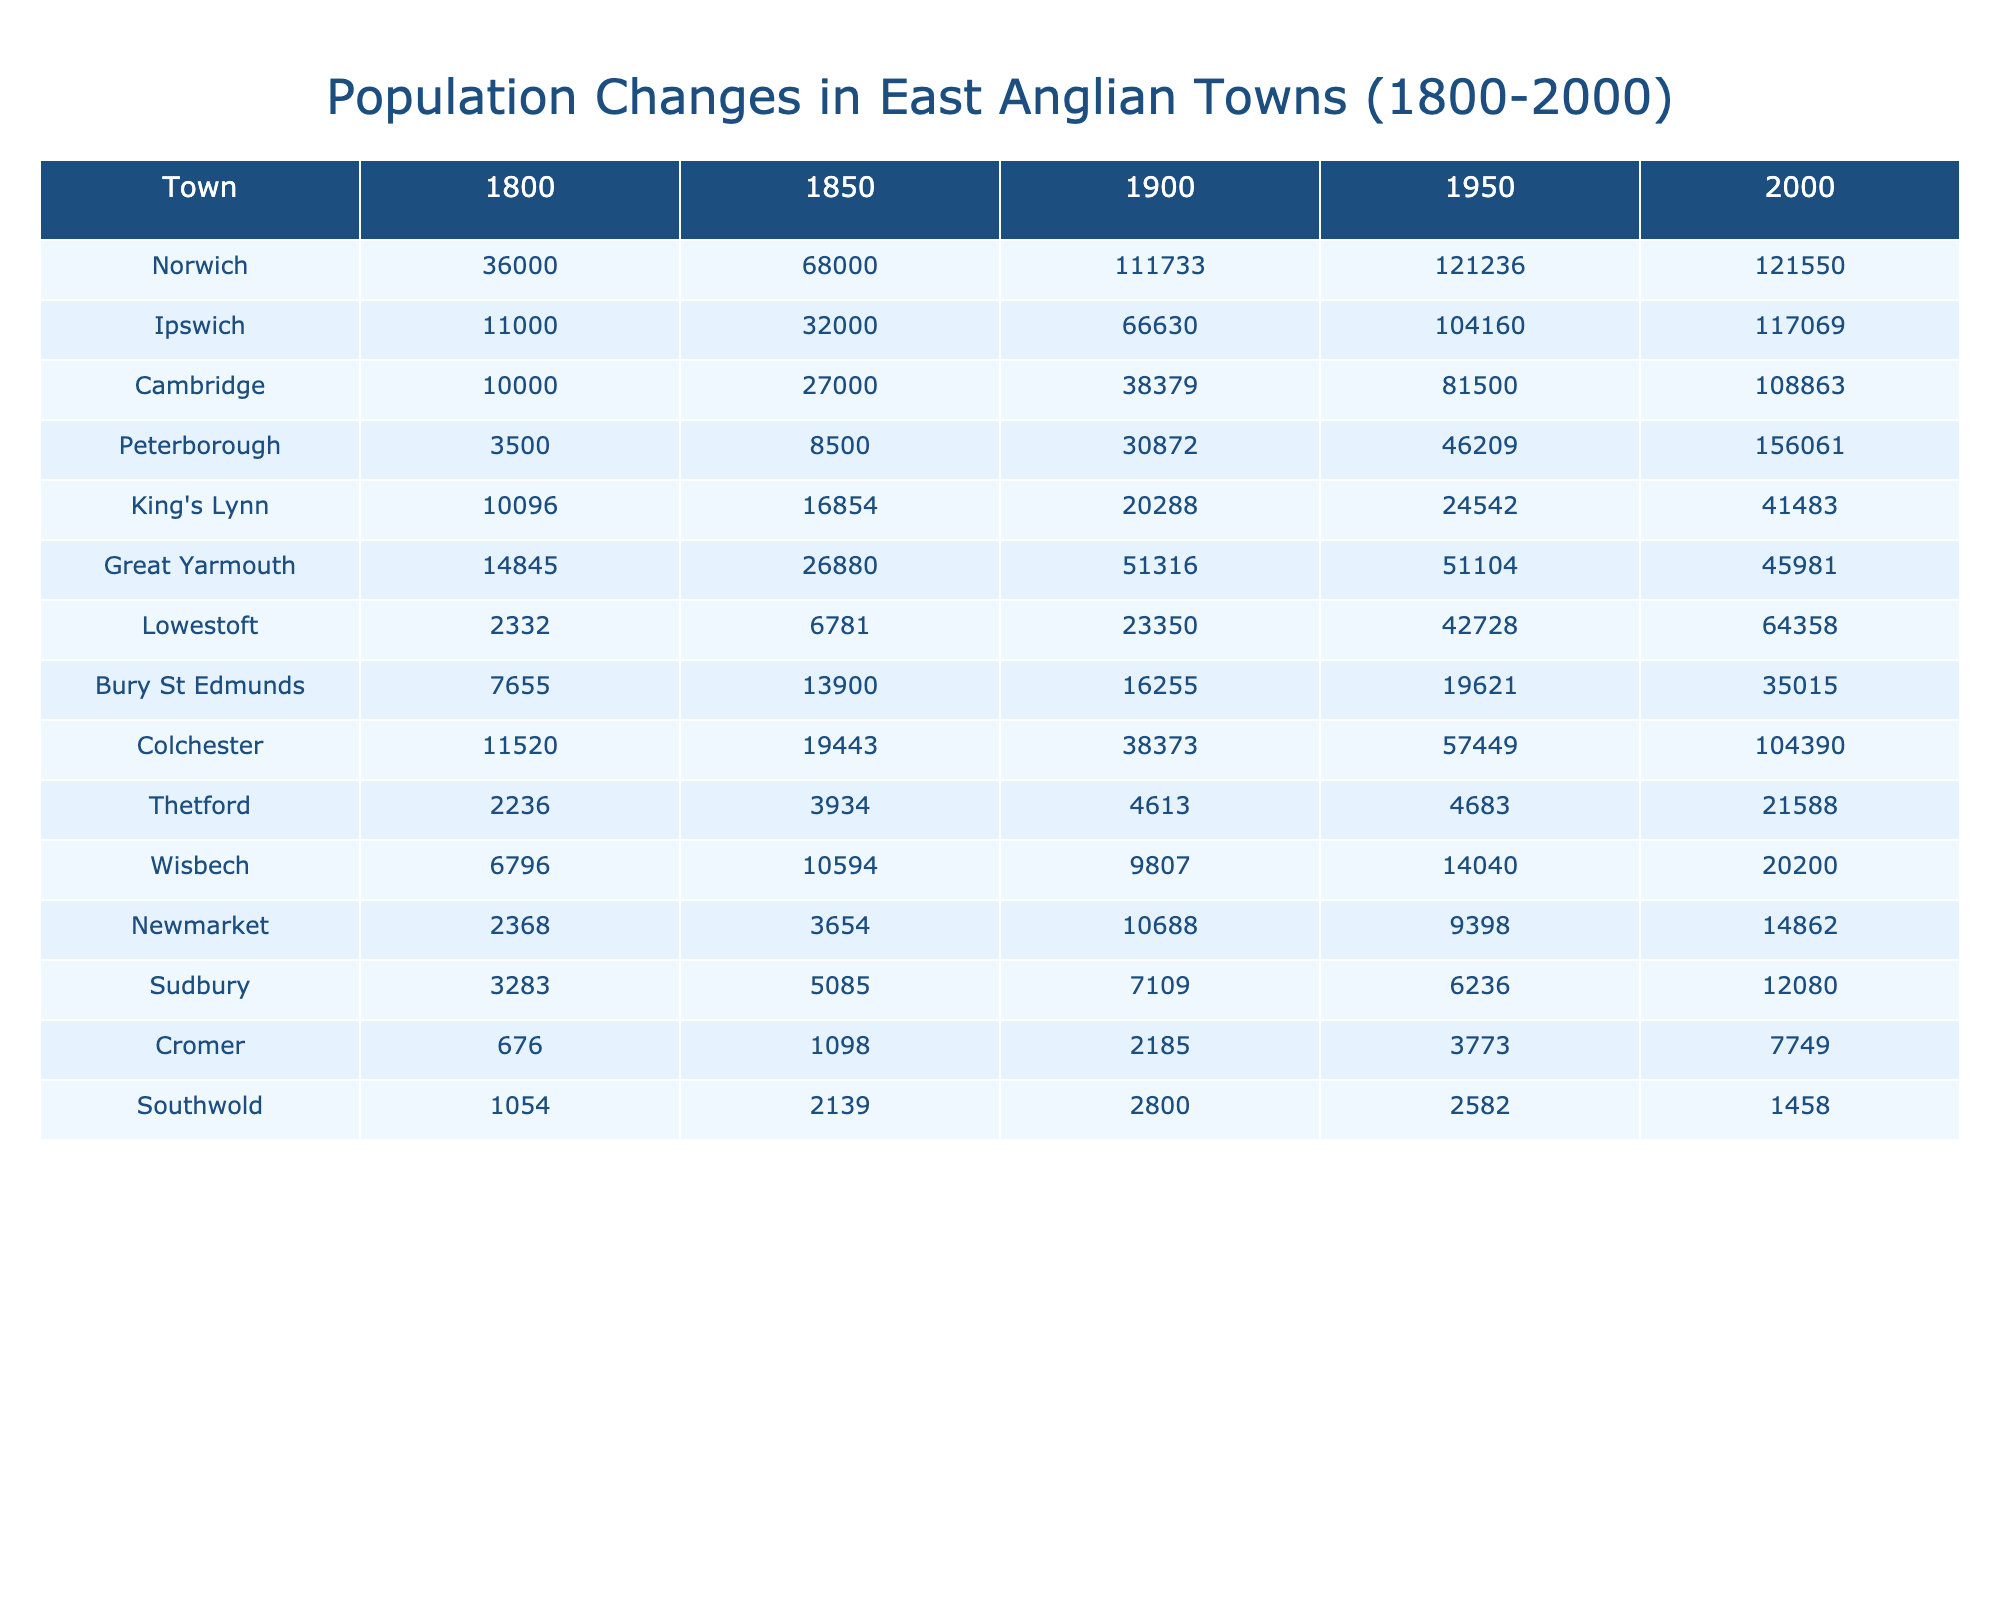What was the population of Norwich in 1900? The table shows the population of Norwich specifically listed under the year 1900, which is 111733.
Answer: 111733 Which town had the smallest population in 1800? By examining the 1800 column, Thetford has the smallest population listed at 2236.
Answer: 2236 What is the difference in population for Ipswich between 2000 and 1950? The population of Ipswich in 2000 is 117069, and in 1950 it is 104160. The difference is calculated as 117069 - 104160 = 2909.
Answer: 2909 Which town experienced the highest population increase from 1800 to 2000? We find the highest value by comparing the populations in 2000 and 1800 for all towns. Peterborough shows the most significant increase from 3500 in 1800 to 156061 in 2000, resulting in a total increase of 152561.
Answer: Peterborough Is the population of Lowestoft greater in 1950 or 2000? The population of Lowestoft in 1950 is 42728, and in 2000, it is 64358. Since 64358 is greater than 42728, the statement is true.
Answer: Yes What was the median population of towns in 1900? The populations in 1900 are sorted as 20288, 38373, 4613, 9807, 111733, and others. Since there are 10 towns, the median will be the average of the 5th and 6th values: (38373 + 51316) / 2 = 44844.5.
Answer: 44844.5 Which town had a population decrease from 1900 to 2000? By comparing the populations in 1900 and 2000 for each town, Great Yarmouth's population decreased from 51316 in 1900 to 45981 in 2000.
Answer: Great Yarmouth What is the total population of all towns in 1850? To find the total for 1850, we add up all the populations listed for that year: 68000 + 32000 + 27000 + 8500 + 16854 + 26880 + 6781 + 13900 + 19443 + 3934 + 10594 + 3654 + 5085 + 2139. The total comes to 246167.
Answer: 246167 Which town had the highest population in 1950? The population for each town in 1950 is compared, and Norwich has the highest population at 121236.
Answer: Norwich How many towns had populations over 100,000 in the year 2000? We check the 2000 column for each town's population and count those over 100,000: Ipswich (117069), Cambridge (108863), Peterborough (156061), and Colchester (104390), which totals four towns.
Answer: 4 